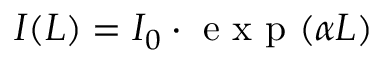<formula> <loc_0><loc_0><loc_500><loc_500>I ( L ) = I _ { 0 } \cdot e x p ( \alpha L )</formula> 